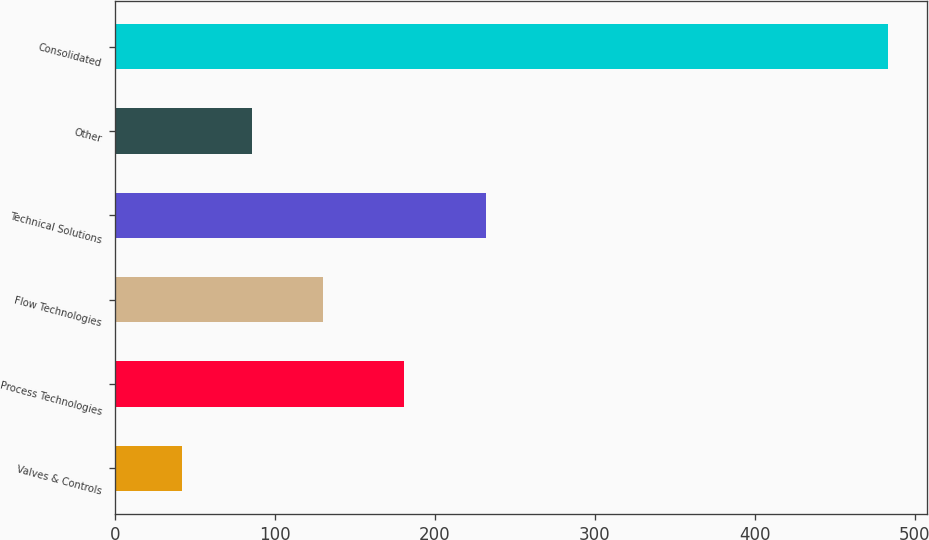<chart> <loc_0><loc_0><loc_500><loc_500><bar_chart><fcel>Valves & Controls<fcel>Process Technologies<fcel>Flow Technologies<fcel>Technical Solutions<fcel>Other<fcel>Consolidated<nl><fcel>41.8<fcel>181.1<fcel>130.14<fcel>232.1<fcel>85.97<fcel>483.5<nl></chart> 